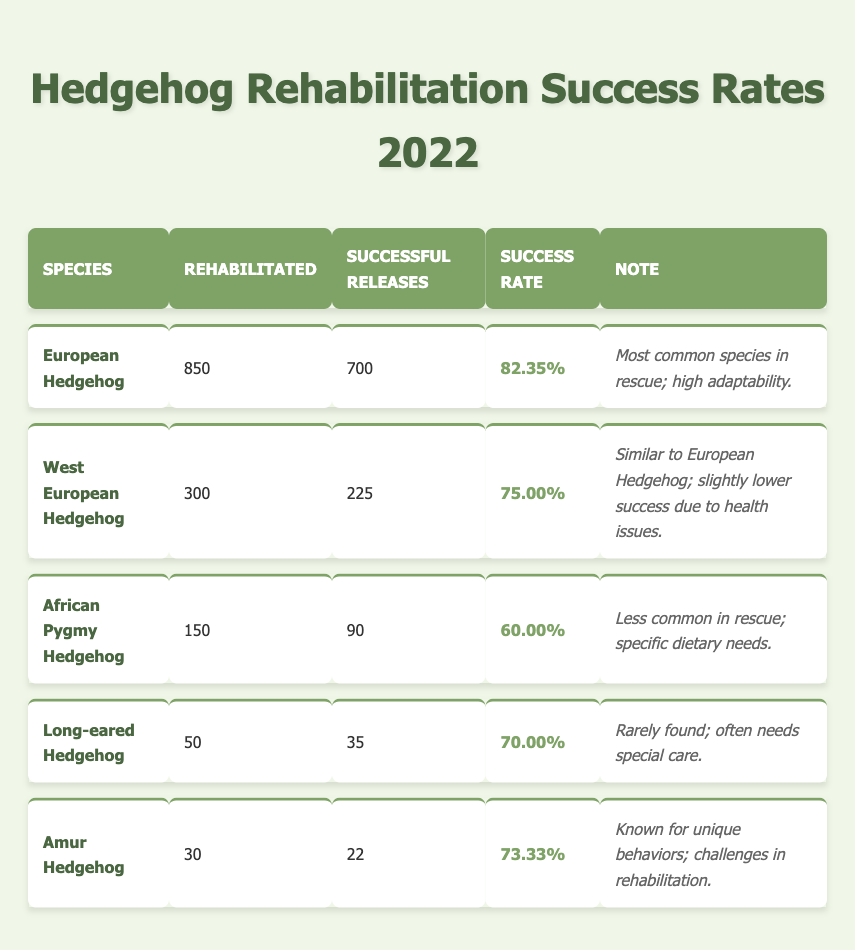What is the success rate of the European Hedgehog? The table lists the success rates for each hedgehog species, and for the European Hedgehog, it shows a success rate of 82.35%.
Answer: 82.35% How many African Pygmy Hedgehogs were rehabilitated? The table indicates that 150 African Pygmy Hedgehogs were rehabilitated.
Answer: 150 Which species had the highest number of successful releases? By comparing the successful releases of each species in the table, the European Hedgehog has the highest with 700 successful releases.
Answer: European Hedgehog What is the success rate of the Long-eared Hedgehog? The Long-eared Hedgehog is listed in the table with a success rate of 70.00%.
Answer: 70.00% What is the total number of hedgehogs rehabilitated across all species? To find the total, we sum the rehabilitated numbers for each species: 850 + 300 + 150 + 50 + 30 = 1380.
Answer: 1380 Is the success rate of the Amur Hedgehog higher than that of the West European Hedgehog? The success rate for the Amur Hedgehog is 73.33% while the West European Hedgehog has a success rate of 75.00%, indicating the Amur Hedgehog's success rate is lower.
Answer: No What percentage of rehabilitated West European Hedgehogs were successfully released? We calculate this by taking the successful releases (225) divided by the total rehabilitated (300), giving us a success rate of (225/300) * 100 = 75.00%.
Answer: 75.00% Which species had the lowest rehabilitation success rate, and what is that rate? From the table, the African Pygmy Hedgehog has the lowest success rate at 60.00%.
Answer: African Pygmy Hedgehog, 60.00% If 100 more European Hedgehogs were rehabilitated, what would the new success rate be if all were successfully released? With 950 rehabilitated (850 + 100) and 700 successful releases + 100 new successful releases = 800, the new success rate is (800/950) * 100 = 84.21%.
Answer: 84.21% How many more African Pygmy Hedgehogs would need to be successfully released to have the same success rate as the Long-eared Hedgehog? The Long-eared Hedgehog's success rate is 70.00%, which means for African Pygmy Hedgehogs (target 60 successful releases total) we need at least (0.70 * 150) = 105 successful releases. With only 90 currently, we need 15 more.
Answer: 15 